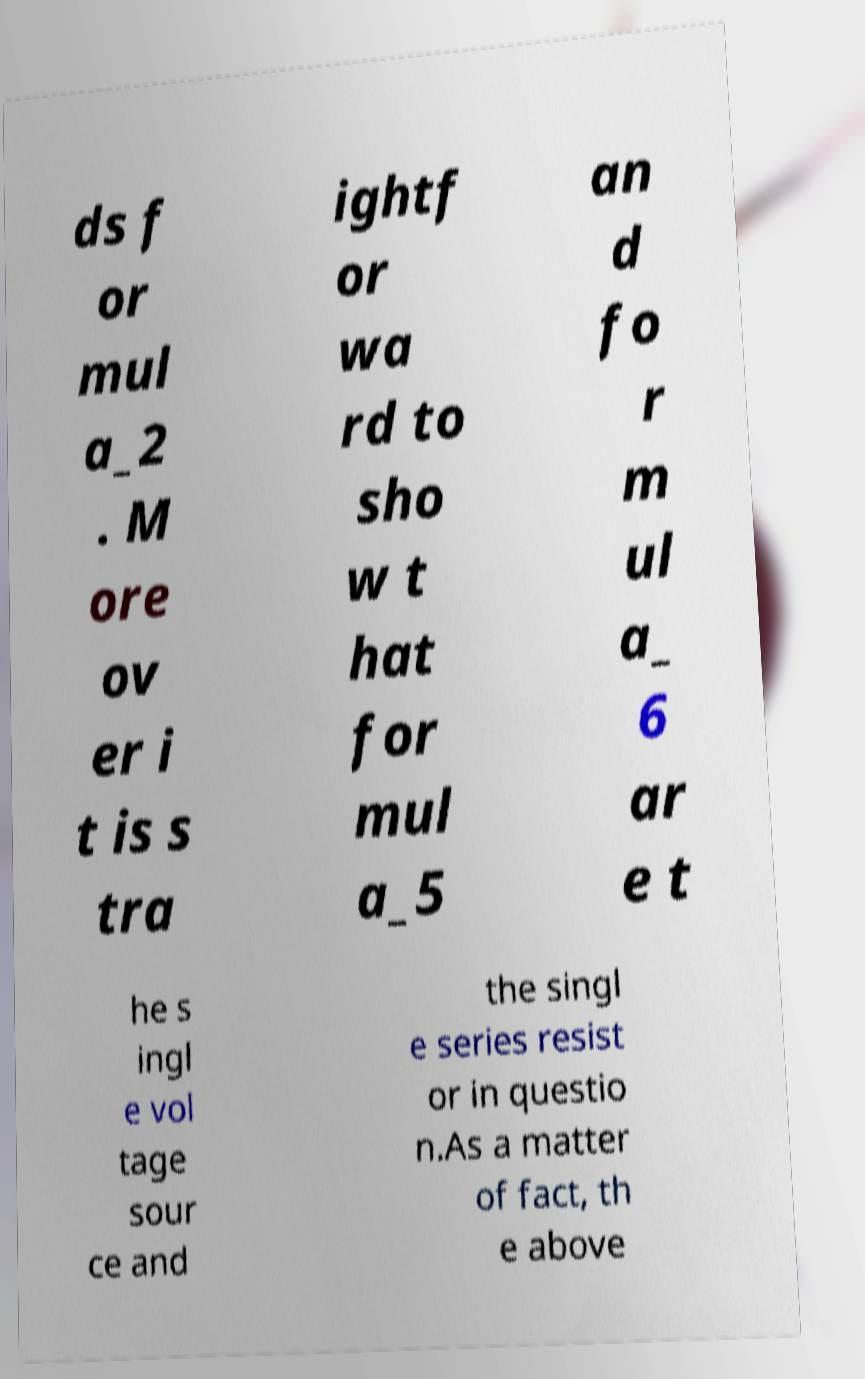For documentation purposes, I need the text within this image transcribed. Could you provide that? ds f or mul a_2 . M ore ov er i t is s tra ightf or wa rd to sho w t hat for mul a_5 an d fo r m ul a_ 6 ar e t he s ingl e vol tage sour ce and the singl e series resist or in questio n.As a matter of fact, th e above 